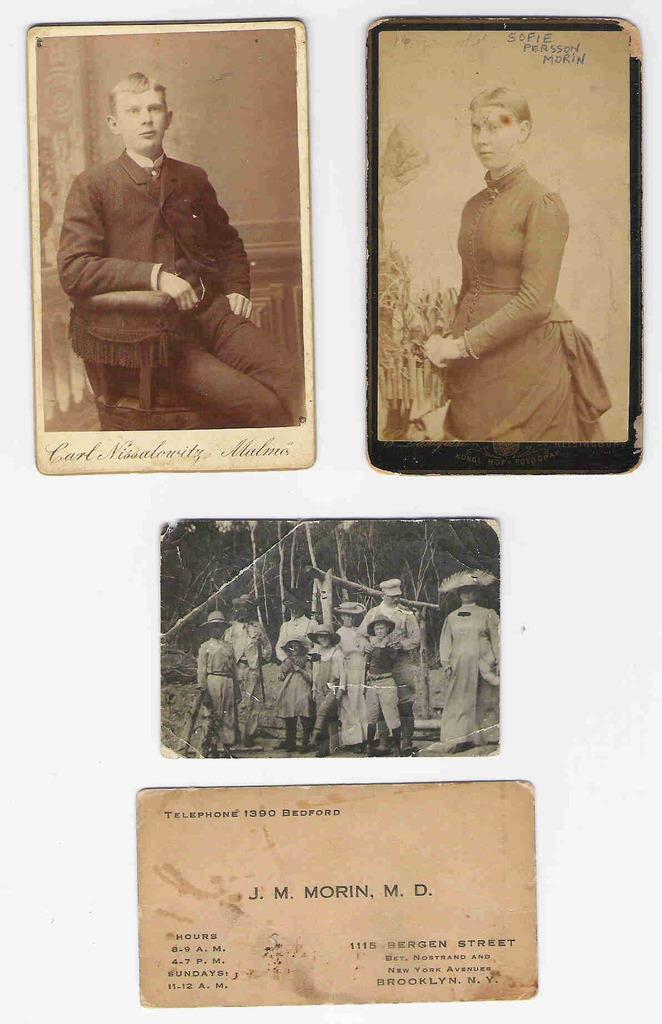How would you summarize this image in a sentence or two? In this image we can see photographs of a persons and a letter. 